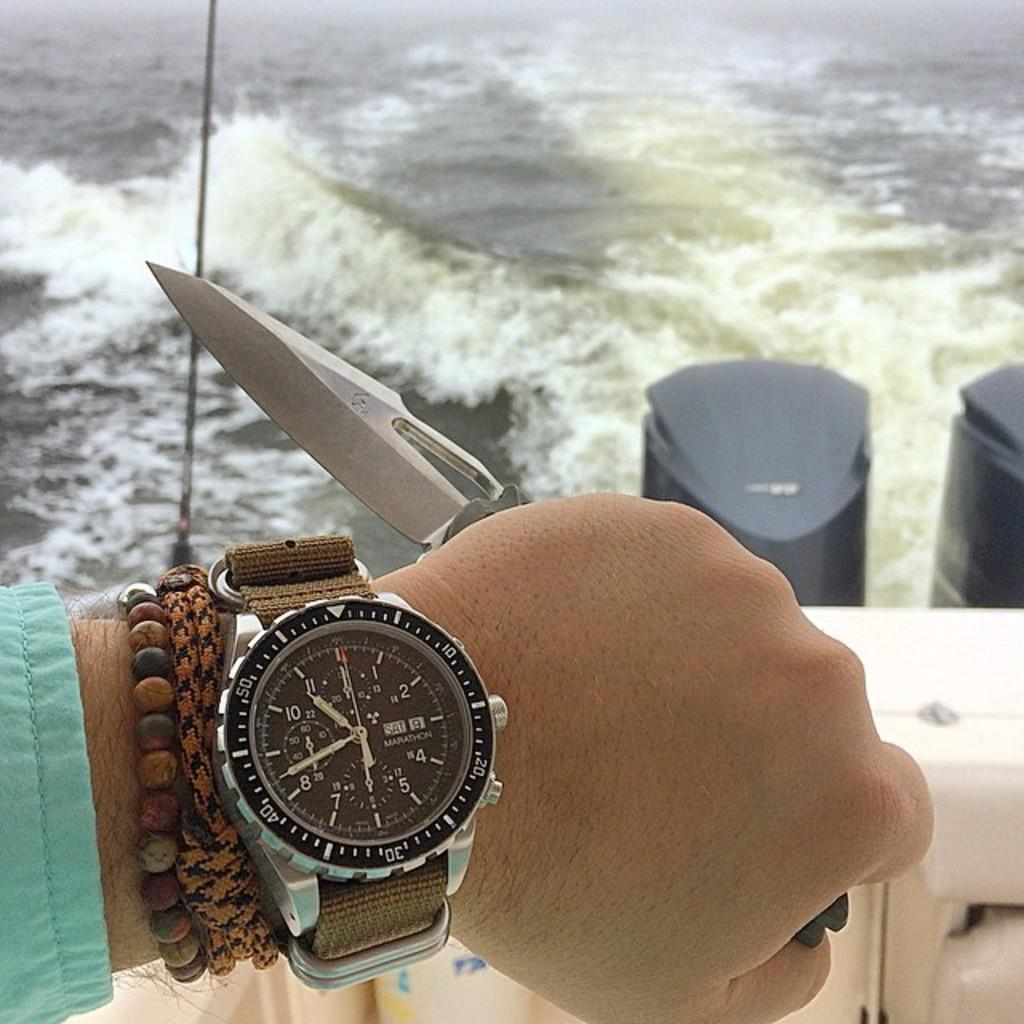<image>
Offer a succinct explanation of the picture presented. A watch with a brown band shows the time of 10:42. 